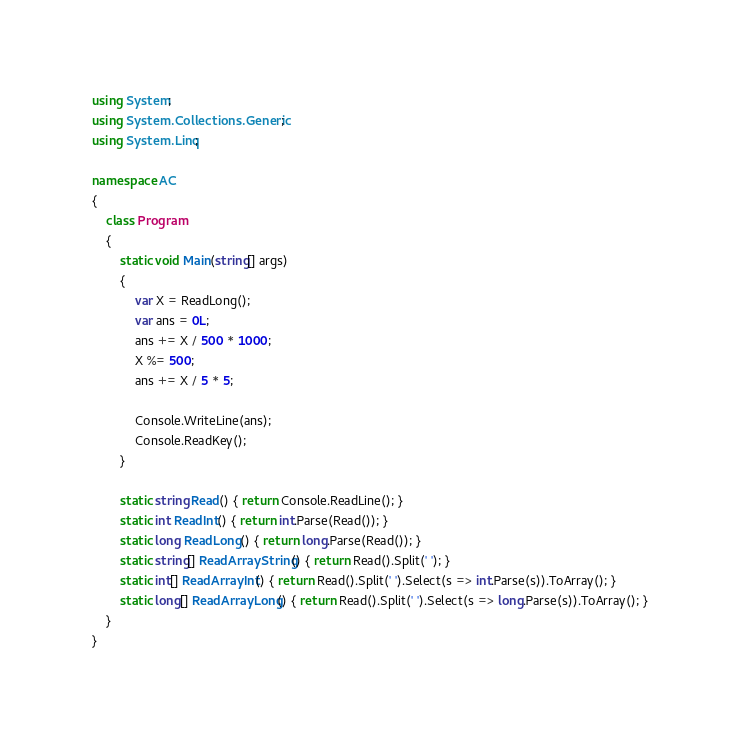Convert code to text. <code><loc_0><loc_0><loc_500><loc_500><_C#_>using System;
using System.Collections.Generic;
using System.Linq;

namespace AC
{
    class Program
    {
        static void Main(string[] args)
        {
            var X = ReadLong();
            var ans = 0L;
            ans += X / 500 * 1000;
            X %= 500;
            ans += X / 5 * 5;

            Console.WriteLine(ans);
            Console.ReadKey();
        }

        static string Read() { return Console.ReadLine(); }
        static int ReadInt() { return int.Parse(Read()); }
        static long ReadLong() { return long.Parse(Read()); }
        static string[] ReadArrayString() { return Read().Split(' '); }
        static int[] ReadArrayInt() { return Read().Split(' ').Select(s => int.Parse(s)).ToArray(); }
        static long[] ReadArrayLong() { return Read().Split(' ').Select(s => long.Parse(s)).ToArray(); }
    }
}
</code> 